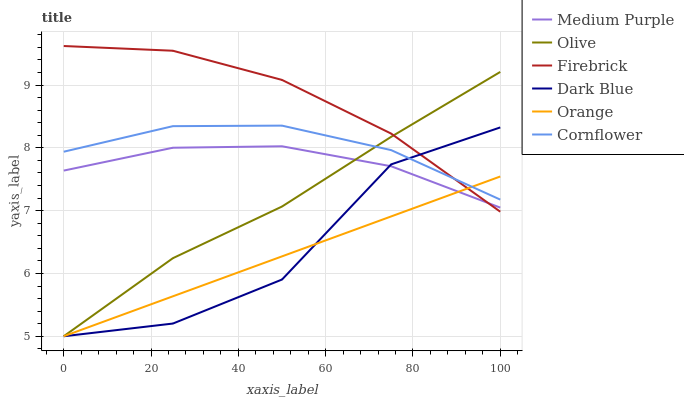Does Orange have the minimum area under the curve?
Answer yes or no. Yes. Does Firebrick have the maximum area under the curve?
Answer yes or no. Yes. Does Dark Blue have the minimum area under the curve?
Answer yes or no. No. Does Dark Blue have the maximum area under the curve?
Answer yes or no. No. Is Orange the smoothest?
Answer yes or no. Yes. Is Dark Blue the roughest?
Answer yes or no. Yes. Is Firebrick the smoothest?
Answer yes or no. No. Is Firebrick the roughest?
Answer yes or no. No. Does Dark Blue have the lowest value?
Answer yes or no. Yes. Does Firebrick have the lowest value?
Answer yes or no. No. Does Firebrick have the highest value?
Answer yes or no. Yes. Does Dark Blue have the highest value?
Answer yes or no. No. Is Medium Purple less than Cornflower?
Answer yes or no. Yes. Is Cornflower greater than Medium Purple?
Answer yes or no. Yes. Does Medium Purple intersect Firebrick?
Answer yes or no. Yes. Is Medium Purple less than Firebrick?
Answer yes or no. No. Is Medium Purple greater than Firebrick?
Answer yes or no. No. Does Medium Purple intersect Cornflower?
Answer yes or no. No. 